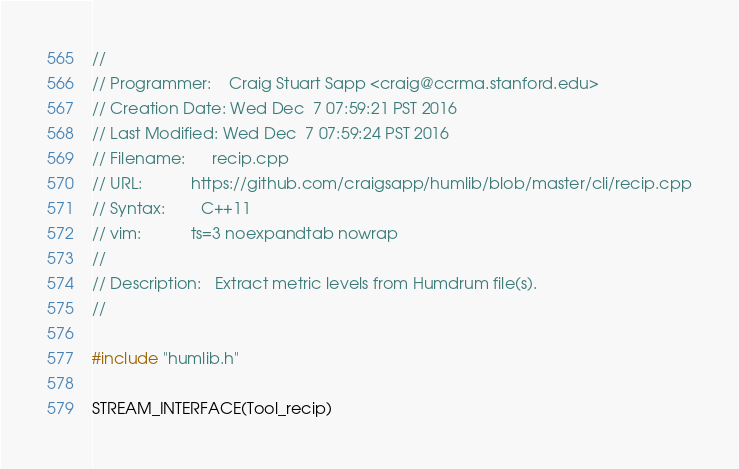Convert code to text. <code><loc_0><loc_0><loc_500><loc_500><_C++_>//
// Programmer:    Craig Stuart Sapp <craig@ccrma.stanford.edu>
// Creation Date: Wed Dec  7 07:59:21 PST 2016
// Last Modified: Wed Dec  7 07:59:24 PST 2016
// Filename:      recip.cpp
// URL:           https://github.com/craigsapp/humlib/blob/master/cli/recip.cpp
// Syntax:        C++11
// vim:           ts=3 noexpandtab nowrap
//
// Description:   Extract metric levels from Humdrum file(s).
//

#include "humlib.h"

STREAM_INTERFACE(Tool_recip)



</code> 